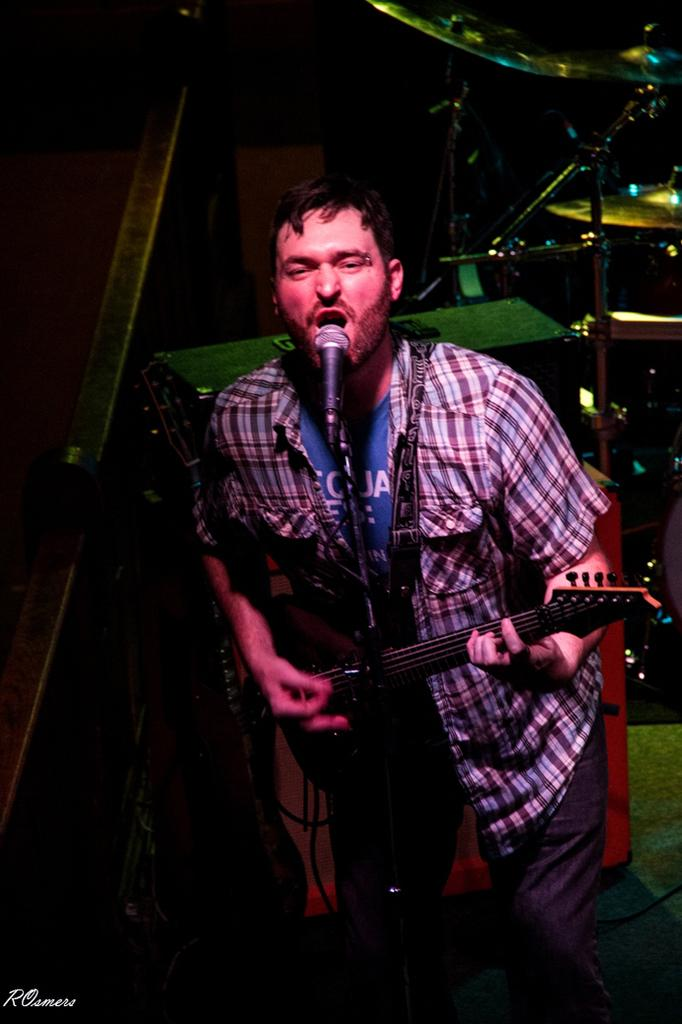What is the man in the image doing? The man is standing, playing a guitar, and singing into a microphone. What musical instruments can be seen in the background? There are cymbals and drums in the background. Can you tell me how many earthquakes have occurred in the image? There is no mention of an earthquake in the image; it features a man playing a guitar and singing into a microphone, with cymbals and drums in the background. Is there a hospital visible in the image? No, there is no hospital present in the image. 